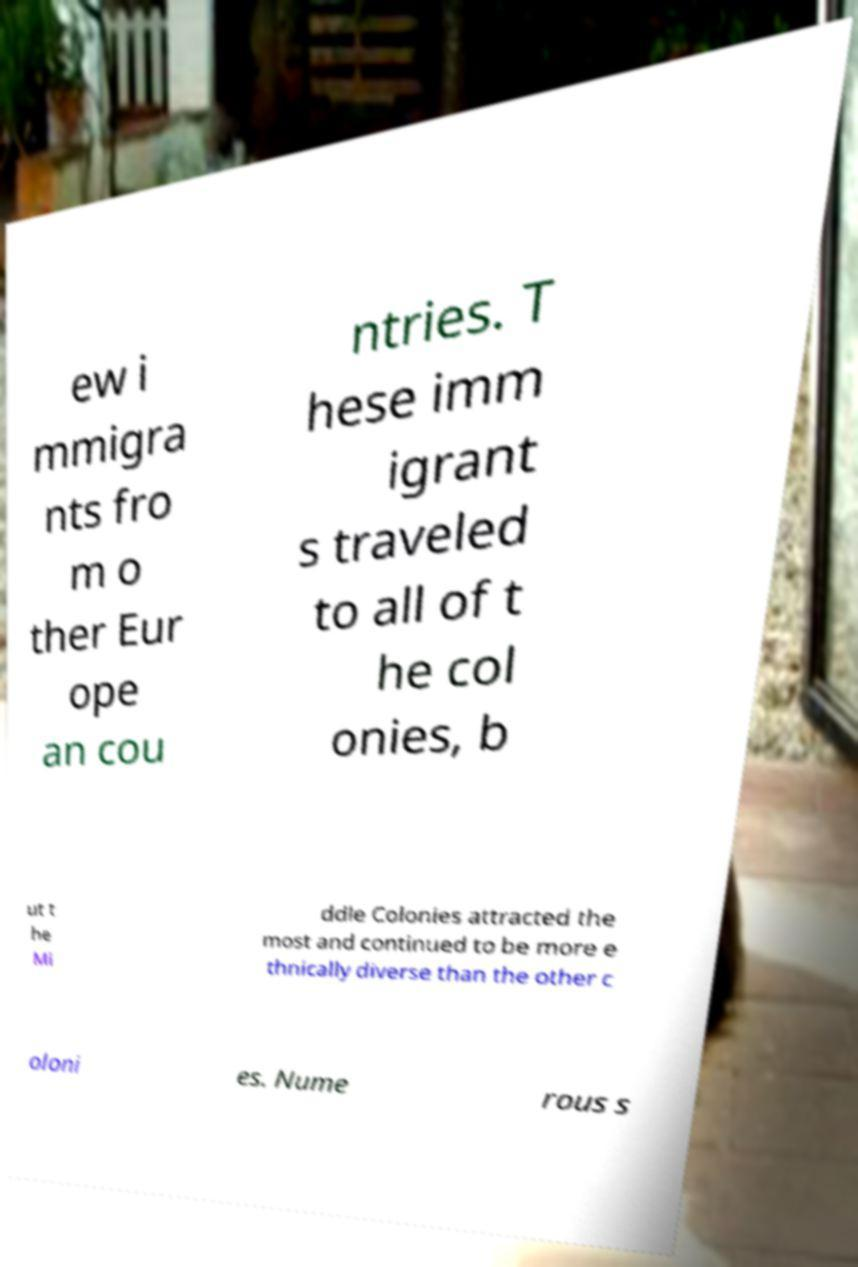Please read and relay the text visible in this image. What does it say? ew i mmigra nts fro m o ther Eur ope an cou ntries. T hese imm igrant s traveled to all of t he col onies, b ut t he Mi ddle Colonies attracted the most and continued to be more e thnically diverse than the other c oloni es. Nume rous s 